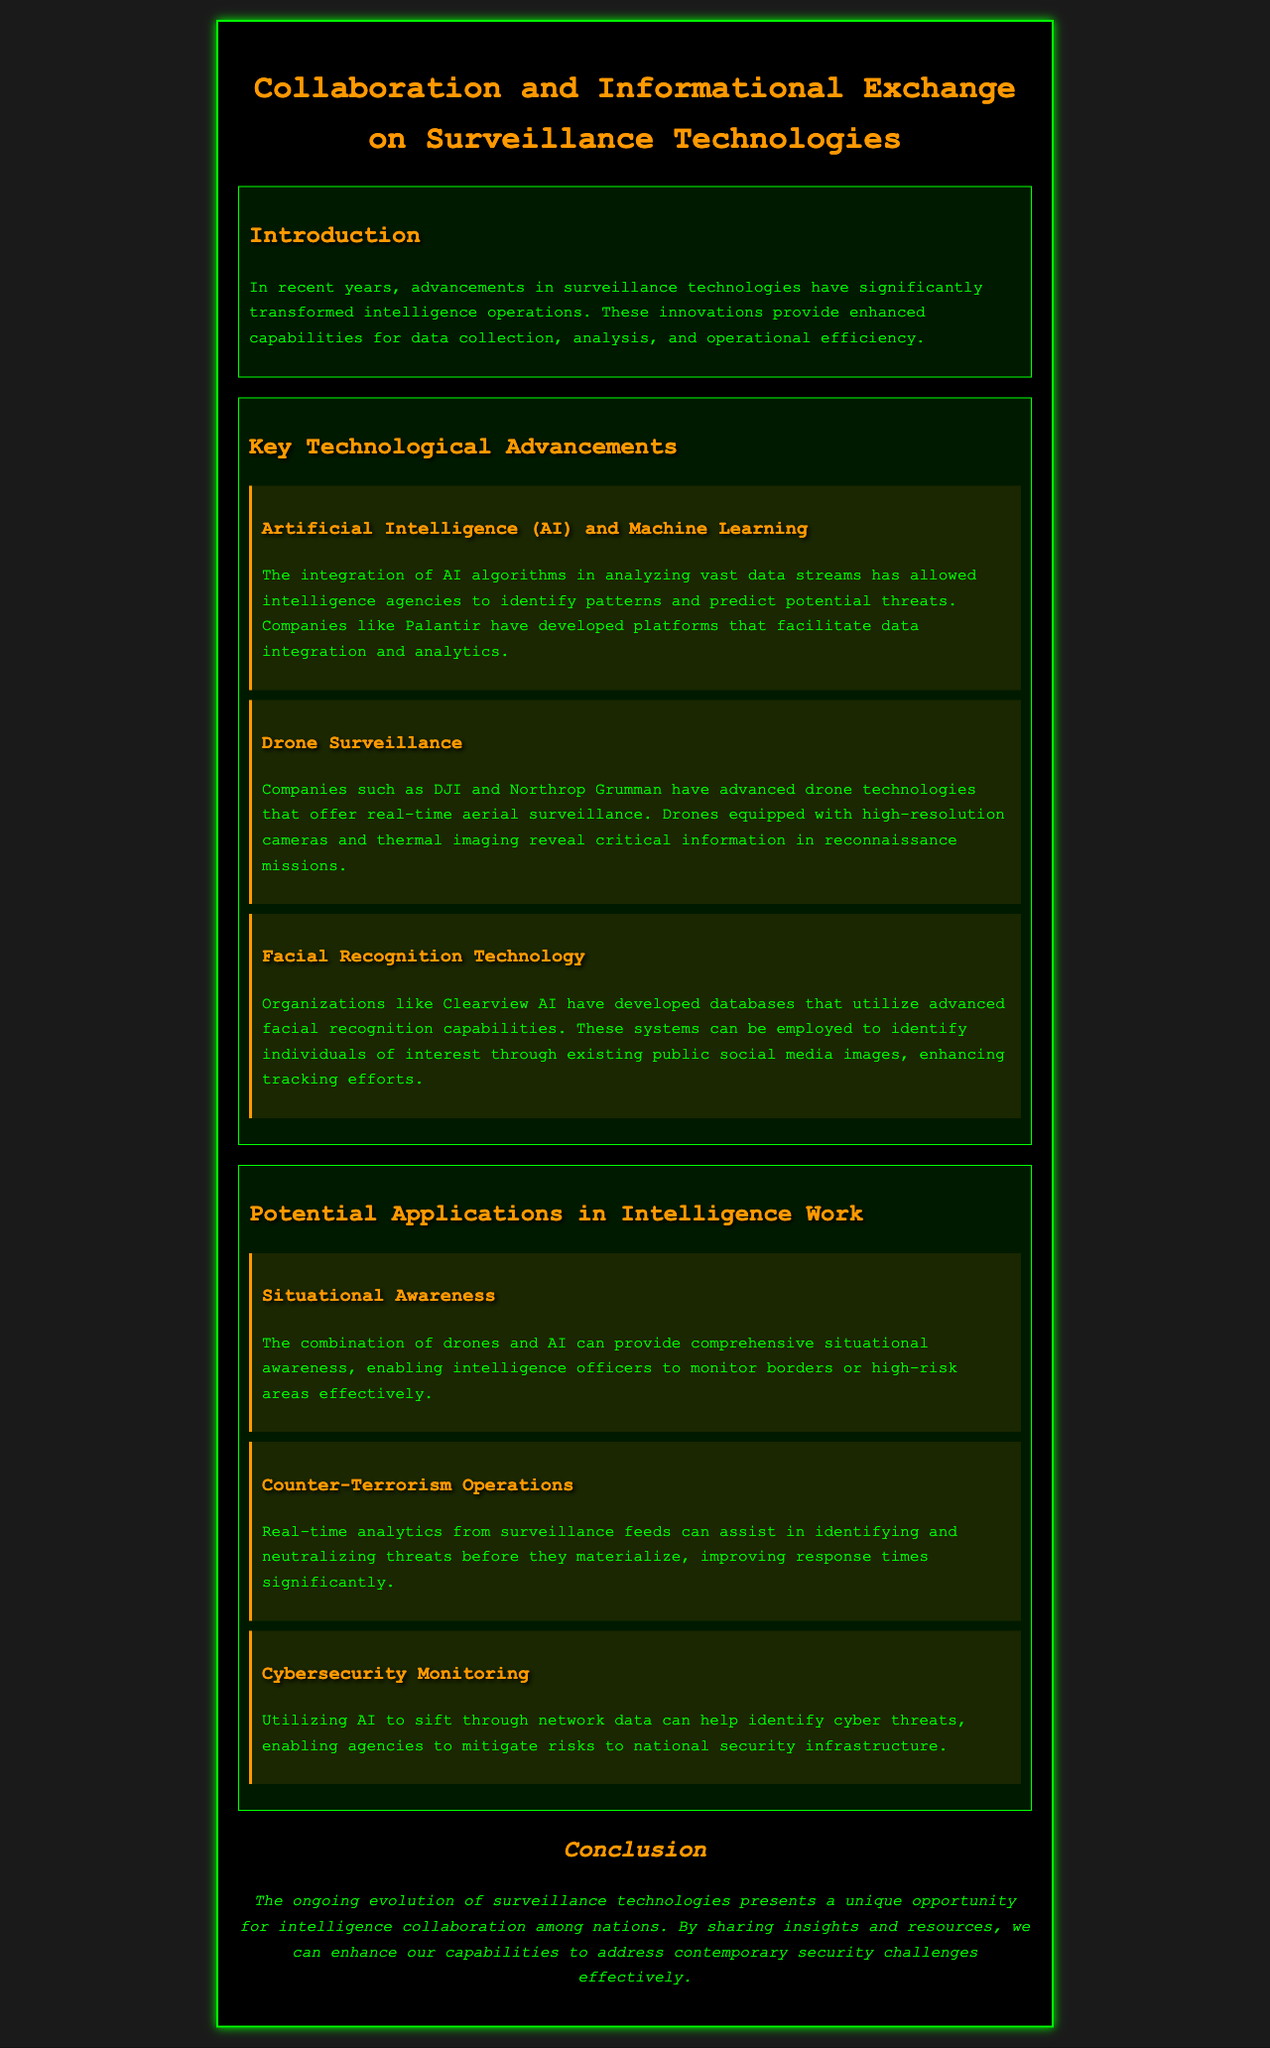What is the title of the document? The title of the document is stated in the HTML structure within the <title> tag.
Answer: Surveillance Technologies Collaboration Who developed the AI and machine learning platforms? The document mentions a specific company known for AI and machine learning platforms that facilitate data integration and analytics.
Answer: Palantir What technology provides real-time aerial surveillance? The document describes a technology that is used for real-time aerial surveillance, highlighting its advanced capabilities.
Answer: Drone Surveillance What database uses advanced facial recognition capabilities? The document references a specific organization that has developed a database employing facial recognition technology.
Answer: Clearview AI What kind of awareness can drones combined with AI provide? The text describes a benefit provided by the combination of certain technologies in intelligence operations, specifically regarding monitoring.
Answer: Situational Awareness Which companies are mentioned in association with drone technologies? The document lists specific companies known for advancing drone technologies related to surveillance.
Answer: DJI and Northrop Grumman What is one application of AI in cybersecurity monitoring? The document indicates a specific role AI can play in cybersecurity within intelligence operations.
Answer: Identifying cyber threats What does the conclusion suggest regarding surveillance technologies? The conclusion provides a suggestion about the implications of advancements in surveillance technologies for international relations.
Answer: Intelligence collaboration How do surveillance advancements impact counter-terrorism? The document discusses the benefits of surveillance technologies specifically in relation to counter-terrorism operations.
Answer: Improved response times 